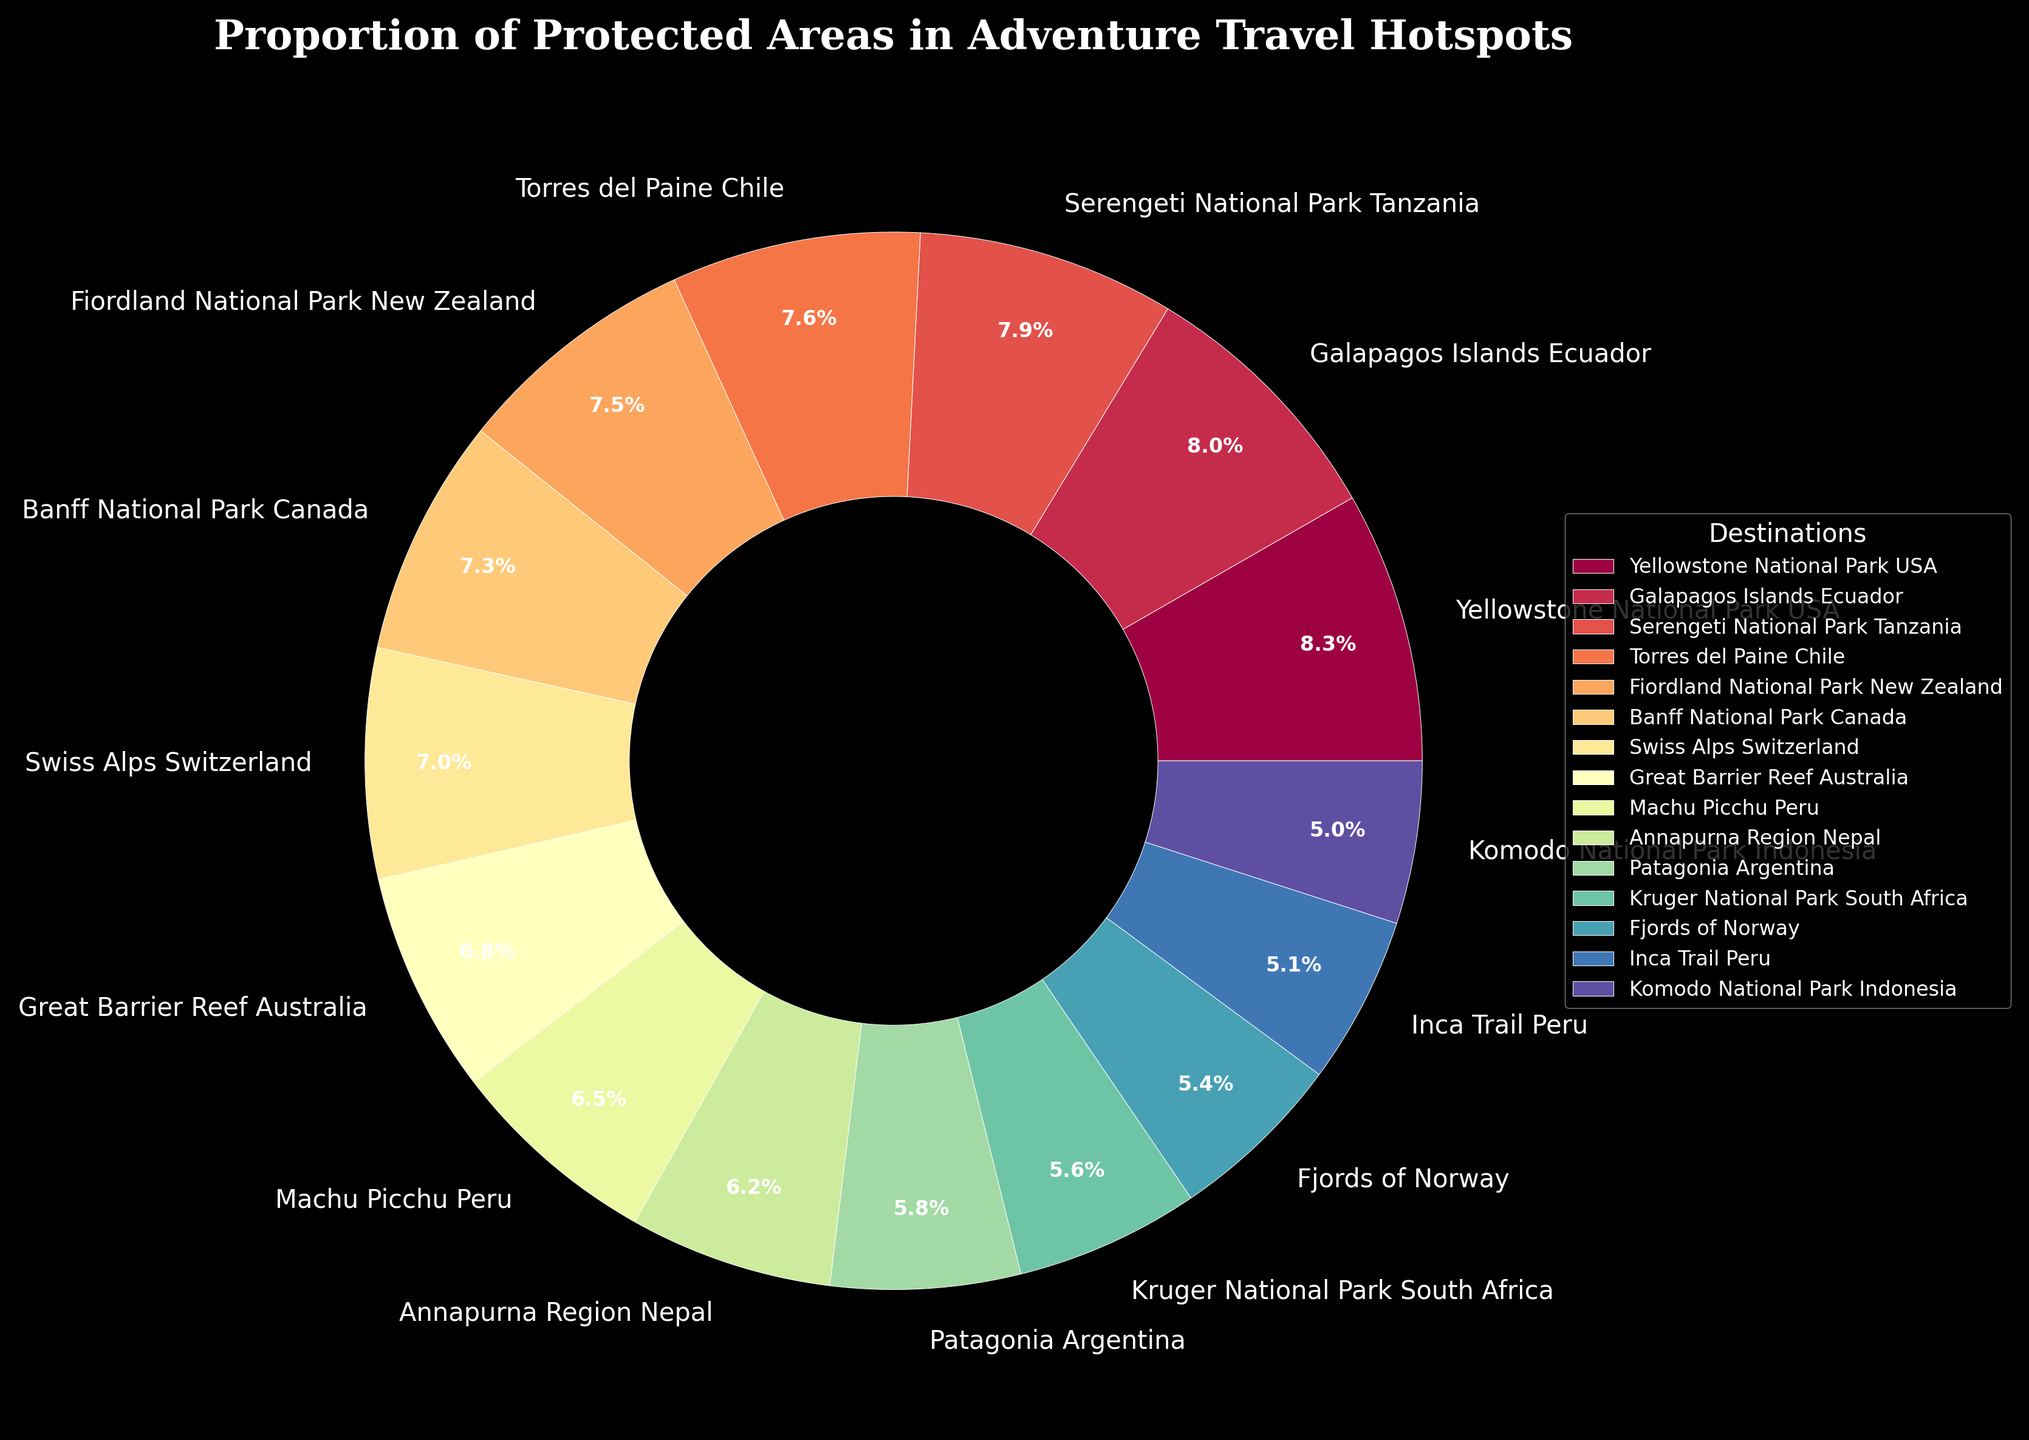What is the destination with the highest proportion of protected areas? The destination with the highest proportion is the one with the largest percentage in the pie chart. Referring to the chart, Yellowstone National Park in the USA has the highest proportion of 100%.
Answer: Yellowstone National Park USA Which destination has a higher percentage of protected areas: Galapagos Islands Ecuador or Sviss Alps Switzerland? Check the percentages in the chart for both destinations. Galapagos Islands Ecuador has 97% and Swiss Alps Switzerland has 85%. Since 97% is greater than 85%, Galapagos Islands Ecuador has a higher percentage.
Answer: Galapagos Islands Ecuador How many destinations have a proportion of protected areas greater than 90%? Count the number of destinations in the pie chart that have percentages higher than 90%. They are Yellowstone National Park USA (100%), Galapagos Islands Ecuador (97%), Serengeti National Park Tanzania (95%), and Torres del Paine Chile (92%). This makes a total of four destinations.
Answer: 4 What is the combined percentage of protected areas for Kruger National Park South Africa and Fjords of Norway? Find the percentages for both destinations from the chart and add them together. Kruger National Park South Africa has 68% and Fjords of Norway has 65%. Adding them gives 68% + 65% = 133%.
Answer: 133% Compare the proportion of protected areas between Machu Picchu Peru and Annapurna Region Nepal. Referring to the chart, Machu Picchu Peru has 78% and Annapurna Region Nepal has 75%. Therefore, Machu Picchu Peru has a slightly higher proportion of protected areas than Annapurna Region Nepal.
Answer: Machu Picchu Peru Which destination has exactly 60% of its area protected? Find the destination in the chart that shows exactly 60%. Komodo National Park Indonesia has 60% of its area protected.
Answer: Komodo National Park Indonesia What is the average percentage of protected areas for the top three destinations? Find the percentages for the top three destinations and calculate the average. The top three are Yellowstone National Park USA (100%), Galapagos Islands Ecuador (97%), and Serengeti National Park Tanzania (95%). The average is (100% + 97% + 95%) / 3 = 97.33%.
Answer: 97.33% Which destination with more than 80% protected area has the smallest proportion? Among the destinations with more than 80% protected, find the one with the smallest value. This is the Great Barrier Reef Australia with 82%.
Answer: Great Barrier Reef Australia 